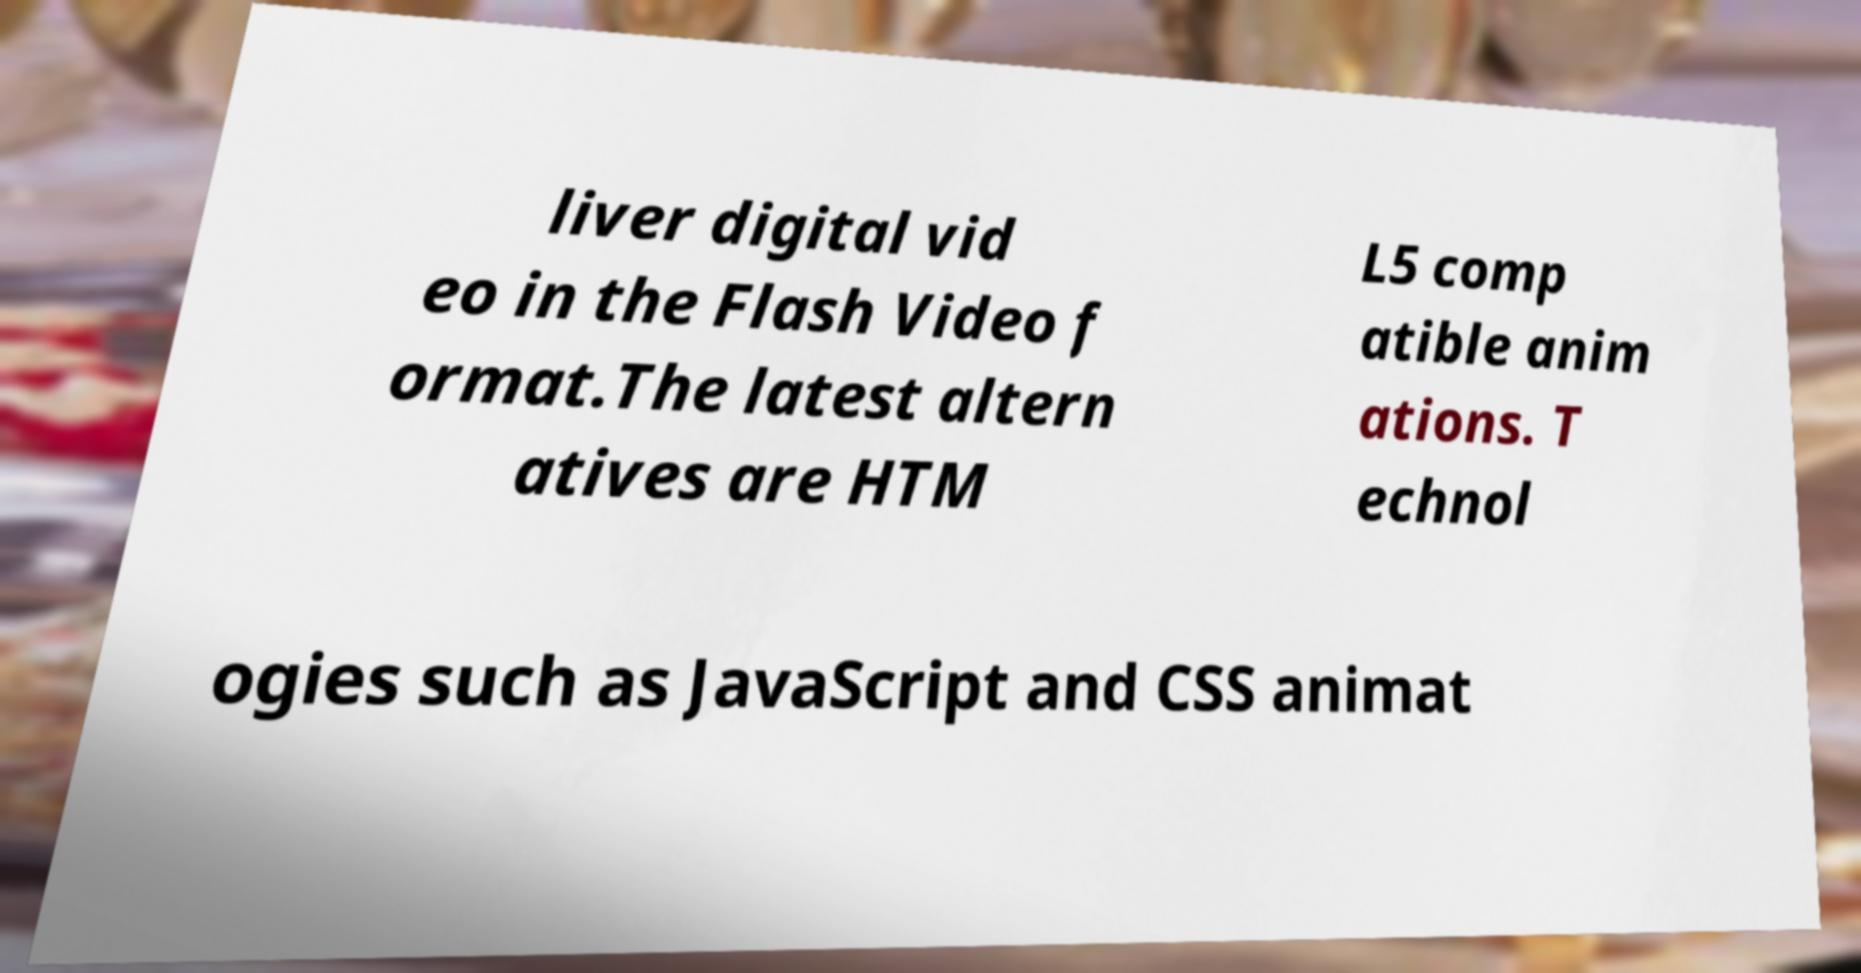Please read and relay the text visible in this image. What does it say? liver digital vid eo in the Flash Video f ormat.The latest altern atives are HTM L5 comp atible anim ations. T echnol ogies such as JavaScript and CSS animat 